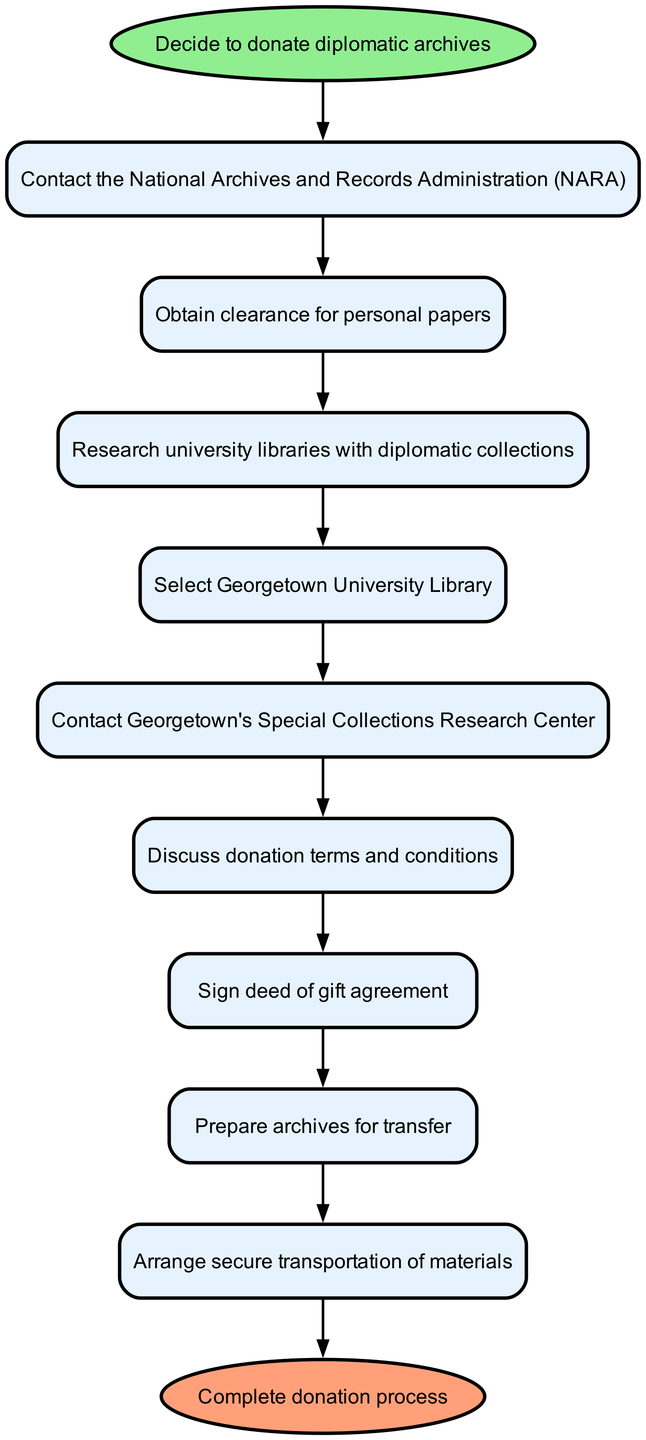What is the first step in the donation process? The first step is explicitly stated as "Decide to donate diplomatic archives", which is the starting point in the flow chart.
Answer: Decide to donate diplomatic archives How many total steps are there in the process? By counting the individual steps between the start and the end nodes, including the start and end nodes themselves, there are a total of ten distinct steps in the process.
Answer: Ten Which entity should be contacted first? The diagram indicates that the first contact should be with the National Archives and Records Administration (NARA), leading directly from the initial decision.
Answer: National Archives and Records Administration What is the last action before the donation is completed? The final action indicated before completing the donation process is to "Arrange secure transportation of materials", which is directly preceding the end step.
Answer: Arrange secure transportation of materials Is there a specific library selected in the process? Yes, the diagram specifies that Georgetown University Library is selected after researching university libraries with diplomatic collections.
Answer: Georgetown University Library What document needs to be signed to finalize the donation? The chart indicates the signing of a "deed of gift agreement" after discussing the terms and conditions of the donation.
Answer: Deed of gift agreement Which step requires obtaining clearance? According to the diagram, obtaining clearance is specified as "Obtain clearance for personal papers", which follows the initial contact with NARA.
Answer: Obtain clearance for personal papers What step involves discussions about donation terms? The flow chart clearly states that the step which involves discussions about the donation terms and conditions directly follows contacting Georgetown's Special Collections Research Center.
Answer: Discuss donation terms and conditions Which step involves physically preparing the archives? The diagram uniquely identifies "Prepare archives for transfer" as the step dedicated to the physical preparation of the archives before their transportation.
Answer: Prepare archives for transfer 